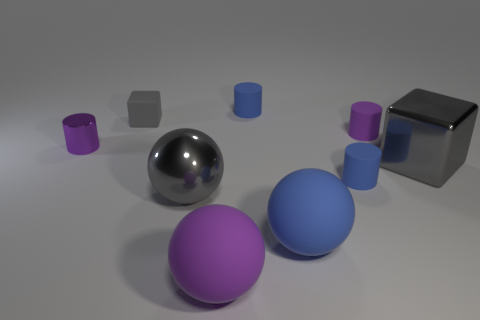There is a block that is right of the large blue rubber thing; is its color the same as the cube that is to the left of the large gray block?
Ensure brevity in your answer.  Yes. Is there a tiny gray matte cube?
Provide a short and direct response. Yes. Is there a tiny purple cylinder made of the same material as the large gray block?
Your answer should be compact. Yes. Are there any other things that are made of the same material as the blue sphere?
Offer a very short reply. Yes. What is the color of the shiny cube?
Give a very brief answer. Gray. There is a tiny rubber object that is the same color as the tiny shiny object; what shape is it?
Your response must be concise. Cylinder. There is a rubber block that is the same size as the purple shiny object; what color is it?
Give a very brief answer. Gray. How many rubber things are tiny spheres or big gray blocks?
Make the answer very short. 0. How many tiny cylinders are both right of the gray matte object and in front of the small gray thing?
Ensure brevity in your answer.  2. What number of other things are the same size as the gray rubber block?
Provide a short and direct response. 4. 